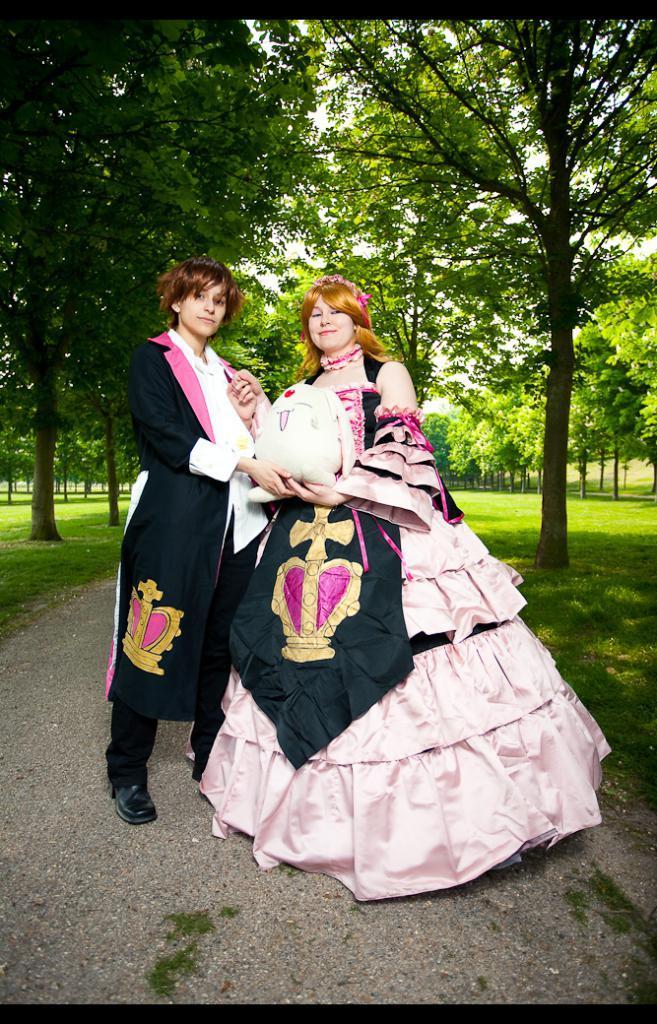Can you describe this image briefly? In this image I can see two people are standing and holding something. In the background I can see few trees in green color. 